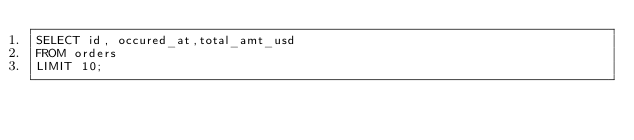<code> <loc_0><loc_0><loc_500><loc_500><_SQL_>SELECT id, occured_at,total_amt_usd
FROM orders
LIMIT 10;
</code> 